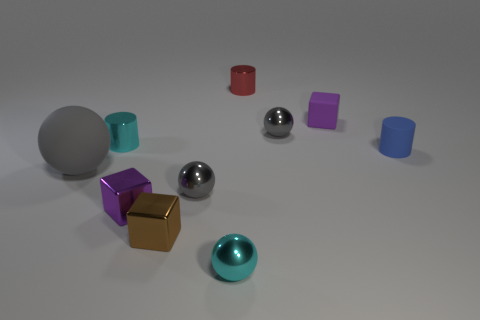There is a cube that is left of the tiny brown block; is there a thing that is to the right of it? Yes, to the right of the tiny brown block, there is a shiny silver sphere. 